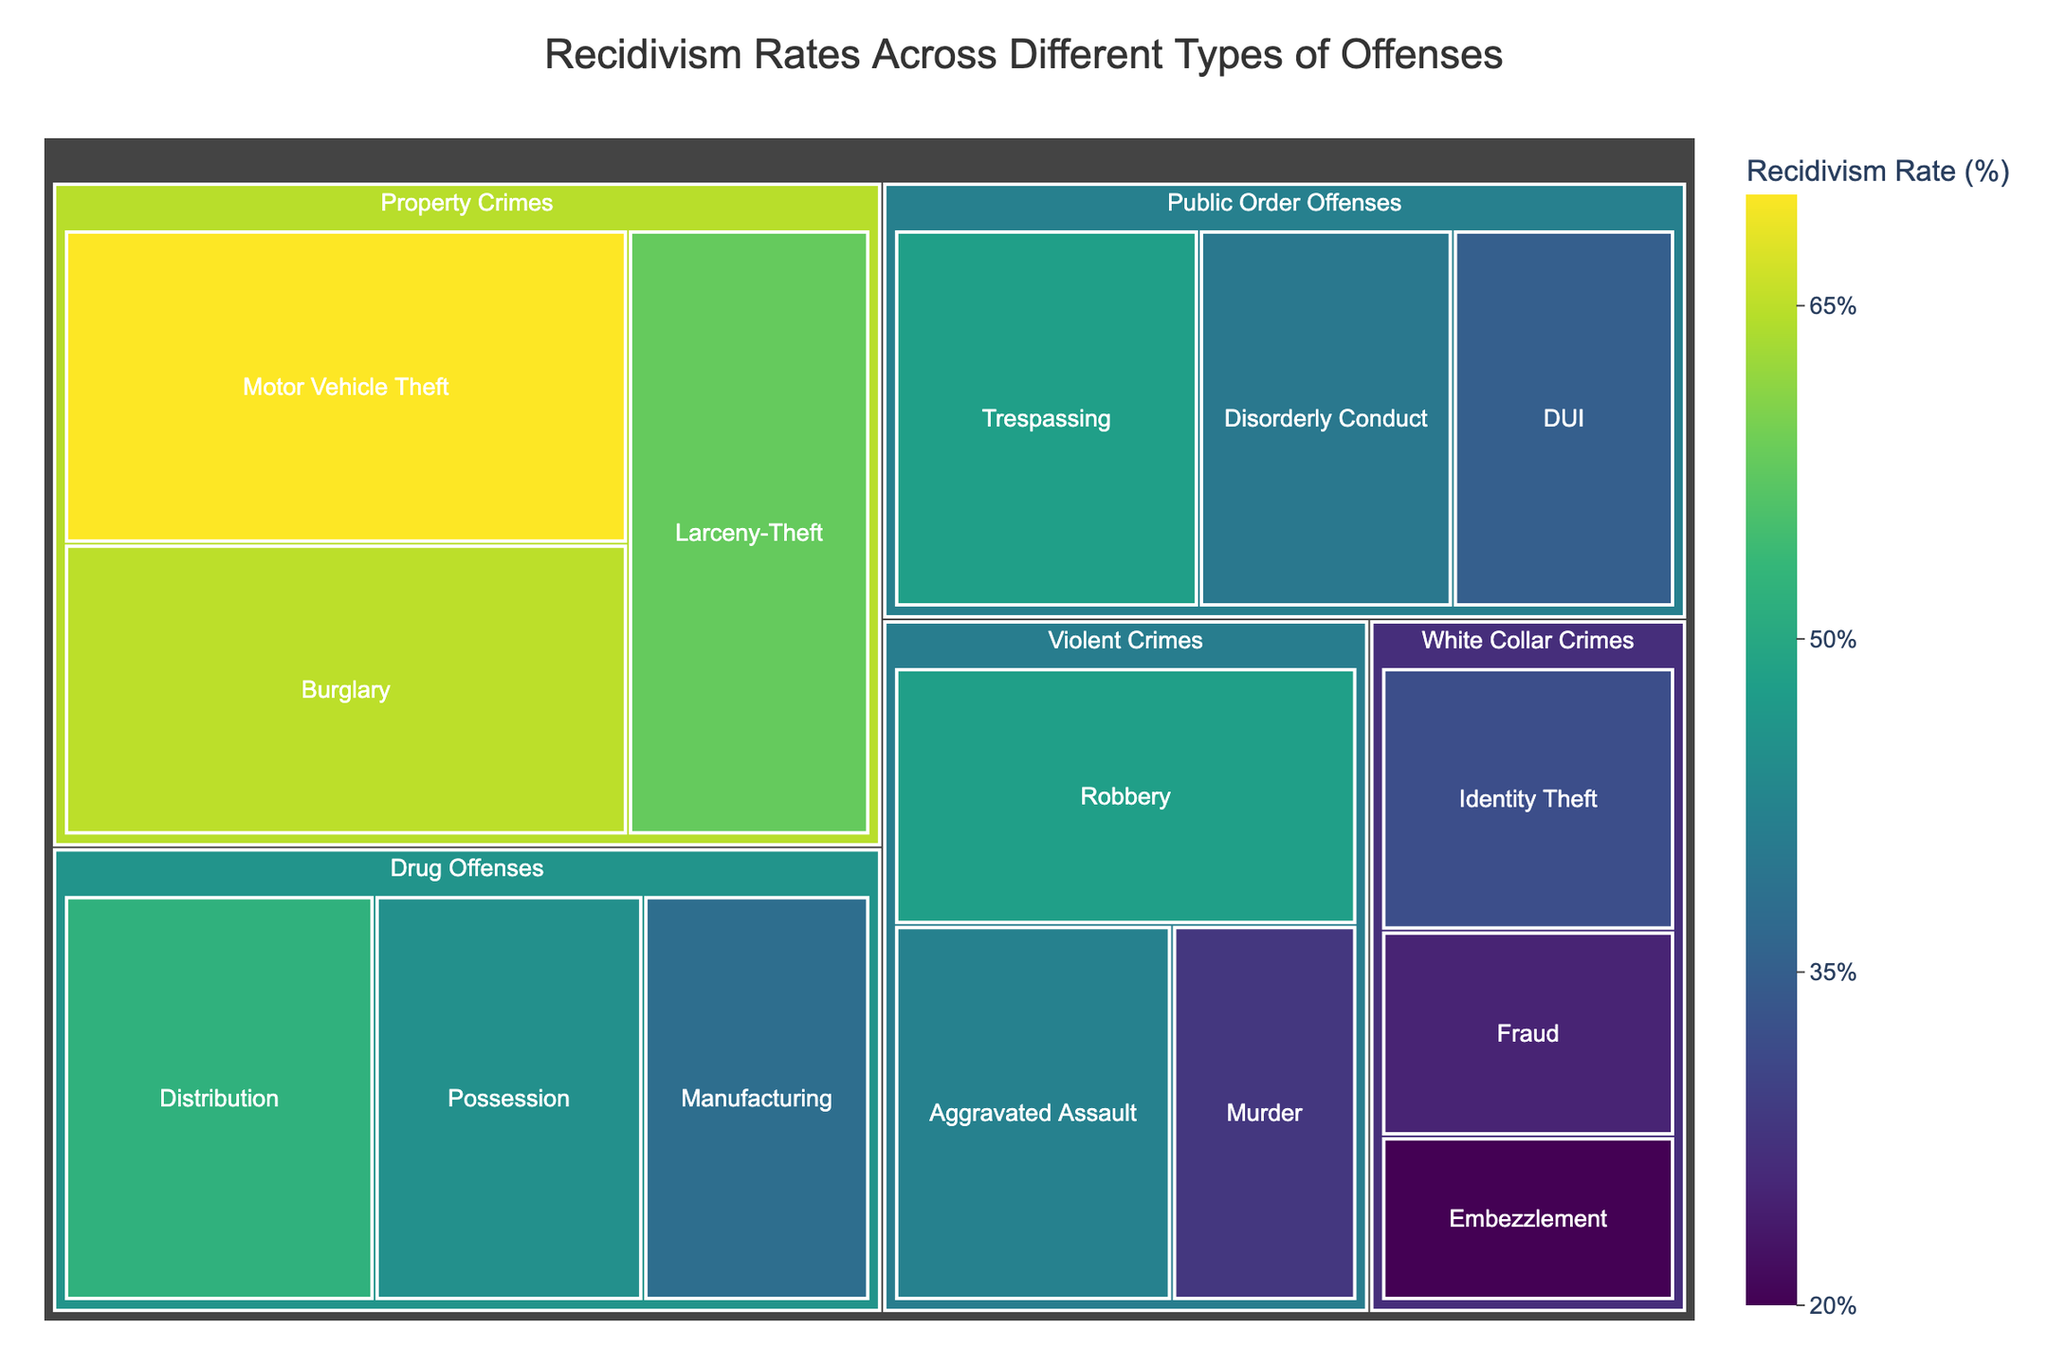What's the title of the figure? The title is typically displayed at the top of the figure. It summarizes the main subject of the plot. In this case, it is "Recidivism Rates Across Different Types of Offenses".
Answer: Recidivism Rates Across Different Types of Offenses What is the recidivism rate for Motor Vehicle Theft? To find the recidivism rate for Motor Vehicle Theft, locate the box labeled "Motor Vehicle Theft" within the "Property Crimes" category in the treemap and identify the percentage given.
Answer: 70% Which category has the lowest overall recidivism rate and what is the value? To determine this, look at each category's highest rate and compare them. The "White Collar Crimes" category contains the lowest rate, specifically with Embezzlement at 20%.
Answer: White Collar Crimes, 20% How does the recidivism rate for Fraud compare to that for Burglary? Locate the boxes for "Fraud" in "White Collar Crimes" and "Burglary" in "Property Crimes". Observe the recidivism rates: Fraud has a rate of 25%, while Burglary has a rate of 65%. Therefore, Fraud has a lower rate.
Answer: Fraud has a lower rate What's the range of recidivism rates among Property Crimes? For the "Property Crimes" category, identify the highest and lowest recidivism rates: Motor Vehicle Theft at 70% and Burglary at 65%. Calculate the range (70% - 65%).
Answer: 5% Among the offenses in the "Drug Offenses" category, which one has the highest recidivism rate? Within the "Drug Offenses" category, compare the recidivism rates of Possession (45%), Distribution (52%), and Manufacturing (38%). The highest rate is 52% for Distribution.
Answer: Distribution at 52% If you combine the recidivism rates of Robbery and Aggravated Assault, what is their average? Sum the recidivism rates for Robbery (48%) and Aggravated Assault (42%), then divide by the number of offenses (2): (48 + 42) / 2 = 45%.
Answer: 45% Which two offenses have the same recidivism rate, and what is the rate? Scan through the rates to see that Robbery and Trespassing, although in different categories, share the same rate of 48%.
Answer: Robbery and Trespassing, 48% What is the difference in recidivism rates between the offense with the highest rate and the one with the lowest rate? Identify the highest rate (Motor Vehicle Theft at 70%) and the lowest rate (Embezzlement at 20%). Subtract the lowest from the highest: 70% - 20% = 50%.
Answer: 50% Which Public Order Offense has the highest recidivism rate? In the "Public Order Offenses" category, compare Disorderly Conduct (40%), DUI (35%), and Trespassing (48%). Trespassing has the highest rate.
Answer: Trespassing at 48% 